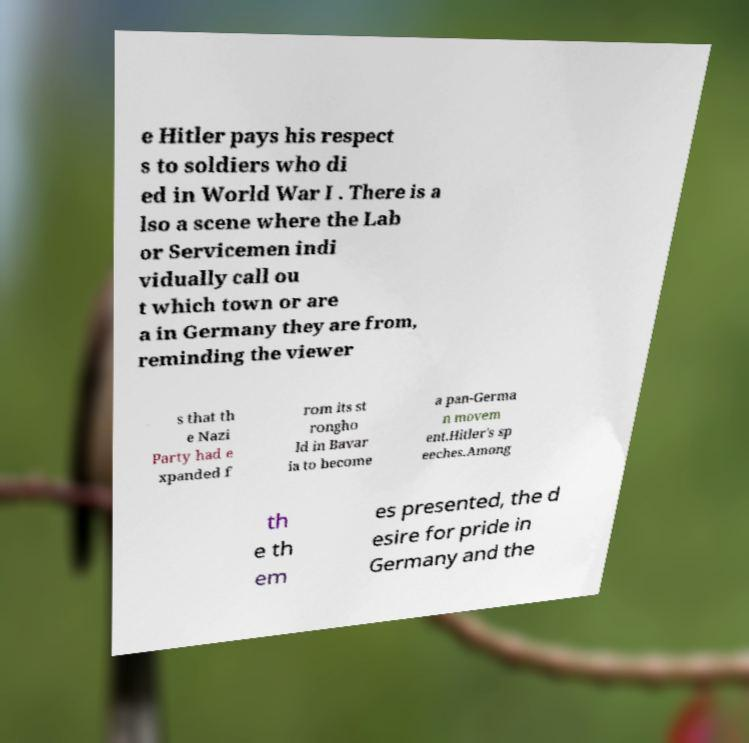Can you accurately transcribe the text from the provided image for me? e Hitler pays his respect s to soldiers who di ed in World War I . There is a lso a scene where the Lab or Servicemen indi vidually call ou t which town or are a in Germany they are from, reminding the viewer s that th e Nazi Party had e xpanded f rom its st rongho ld in Bavar ia to become a pan-Germa n movem ent.Hitler's sp eeches.Among th e th em es presented, the d esire for pride in Germany and the 